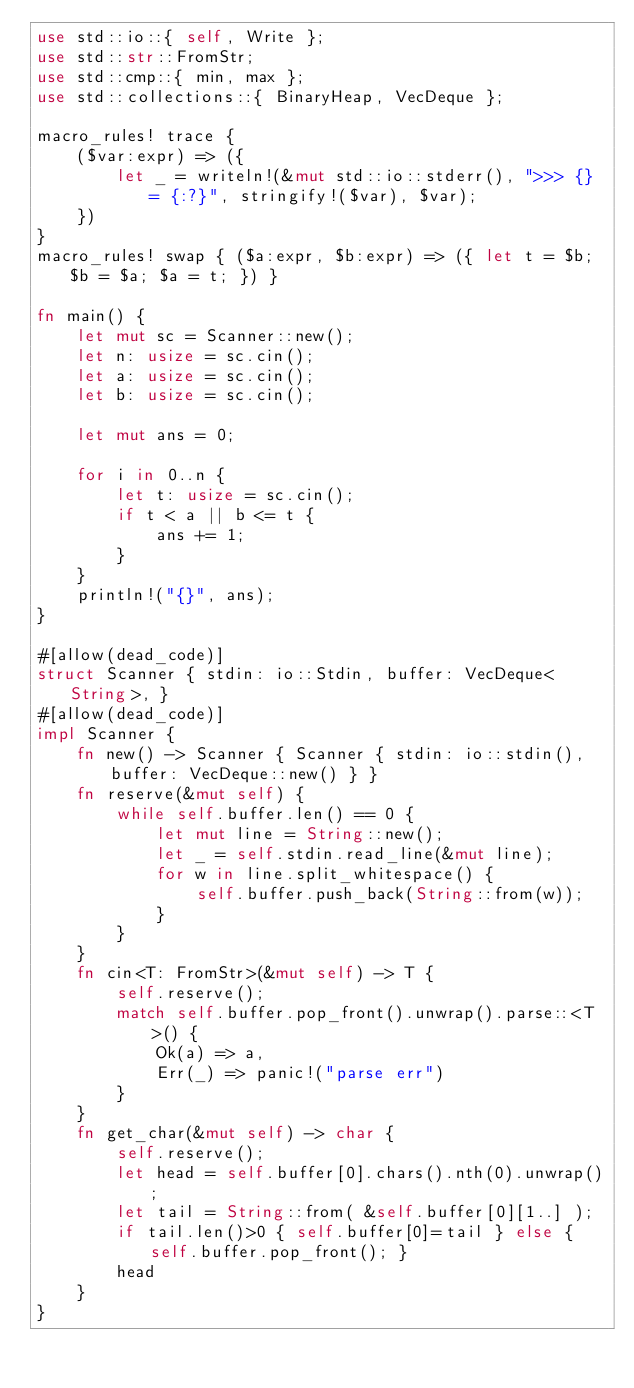Convert code to text. <code><loc_0><loc_0><loc_500><loc_500><_Rust_>use std::io::{ self, Write };
use std::str::FromStr;
use std::cmp::{ min, max };
use std::collections::{ BinaryHeap, VecDeque };

macro_rules! trace {
    ($var:expr) => ({
        let _ = writeln!(&mut std::io::stderr(), ">>> {} = {:?}", stringify!($var), $var);
    })
}
macro_rules! swap { ($a:expr, $b:expr) => ({ let t = $b; $b = $a; $a = t; }) }

fn main() {
    let mut sc = Scanner::new();
    let n: usize = sc.cin();
    let a: usize = sc.cin();
    let b: usize = sc.cin();

    let mut ans = 0;

    for i in 0..n {
        let t: usize = sc.cin();
        if t < a || b <= t {
            ans += 1;
        }
    }
    println!("{}", ans);
}

#[allow(dead_code)]
struct Scanner { stdin: io::Stdin, buffer: VecDeque<String>, }
#[allow(dead_code)]
impl Scanner {
    fn new() -> Scanner { Scanner { stdin: io::stdin(), buffer: VecDeque::new() } }
    fn reserve(&mut self) {
        while self.buffer.len() == 0 {
            let mut line = String::new();
            let _ = self.stdin.read_line(&mut line);
            for w in line.split_whitespace() {
                self.buffer.push_back(String::from(w));
            }
        }
    }
    fn cin<T: FromStr>(&mut self) -> T {
        self.reserve();
        match self.buffer.pop_front().unwrap().parse::<T>() {
            Ok(a) => a,
            Err(_) => panic!("parse err")
        }
    }
    fn get_char(&mut self) -> char {
        self.reserve();
        let head = self.buffer[0].chars().nth(0).unwrap();
        let tail = String::from( &self.buffer[0][1..] );
        if tail.len()>0 { self.buffer[0]=tail } else { self.buffer.pop_front(); }
        head
    }
}
</code> 